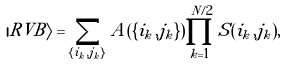<formula> <loc_0><loc_0><loc_500><loc_500>| R V B \rangle = \sum _ { \{ i _ { k } , j _ { k } \} } A ( \{ i _ { k } , j _ { k } \} ) \prod _ { k = 1 } ^ { N / 2 } S ( i _ { k } , j _ { k } ) ,</formula> 